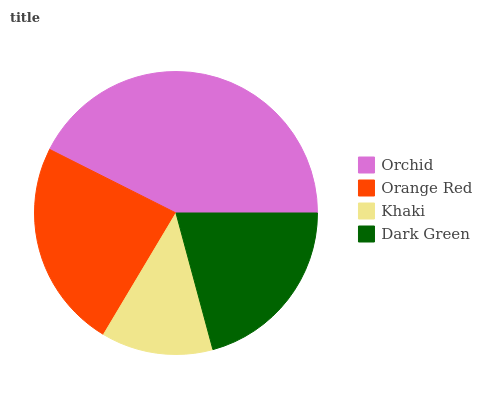Is Khaki the minimum?
Answer yes or no. Yes. Is Orchid the maximum?
Answer yes or no. Yes. Is Orange Red the minimum?
Answer yes or no. No. Is Orange Red the maximum?
Answer yes or no. No. Is Orchid greater than Orange Red?
Answer yes or no. Yes. Is Orange Red less than Orchid?
Answer yes or no. Yes. Is Orange Red greater than Orchid?
Answer yes or no. No. Is Orchid less than Orange Red?
Answer yes or no. No. Is Orange Red the high median?
Answer yes or no. Yes. Is Dark Green the low median?
Answer yes or no. Yes. Is Khaki the high median?
Answer yes or no. No. Is Khaki the low median?
Answer yes or no. No. 